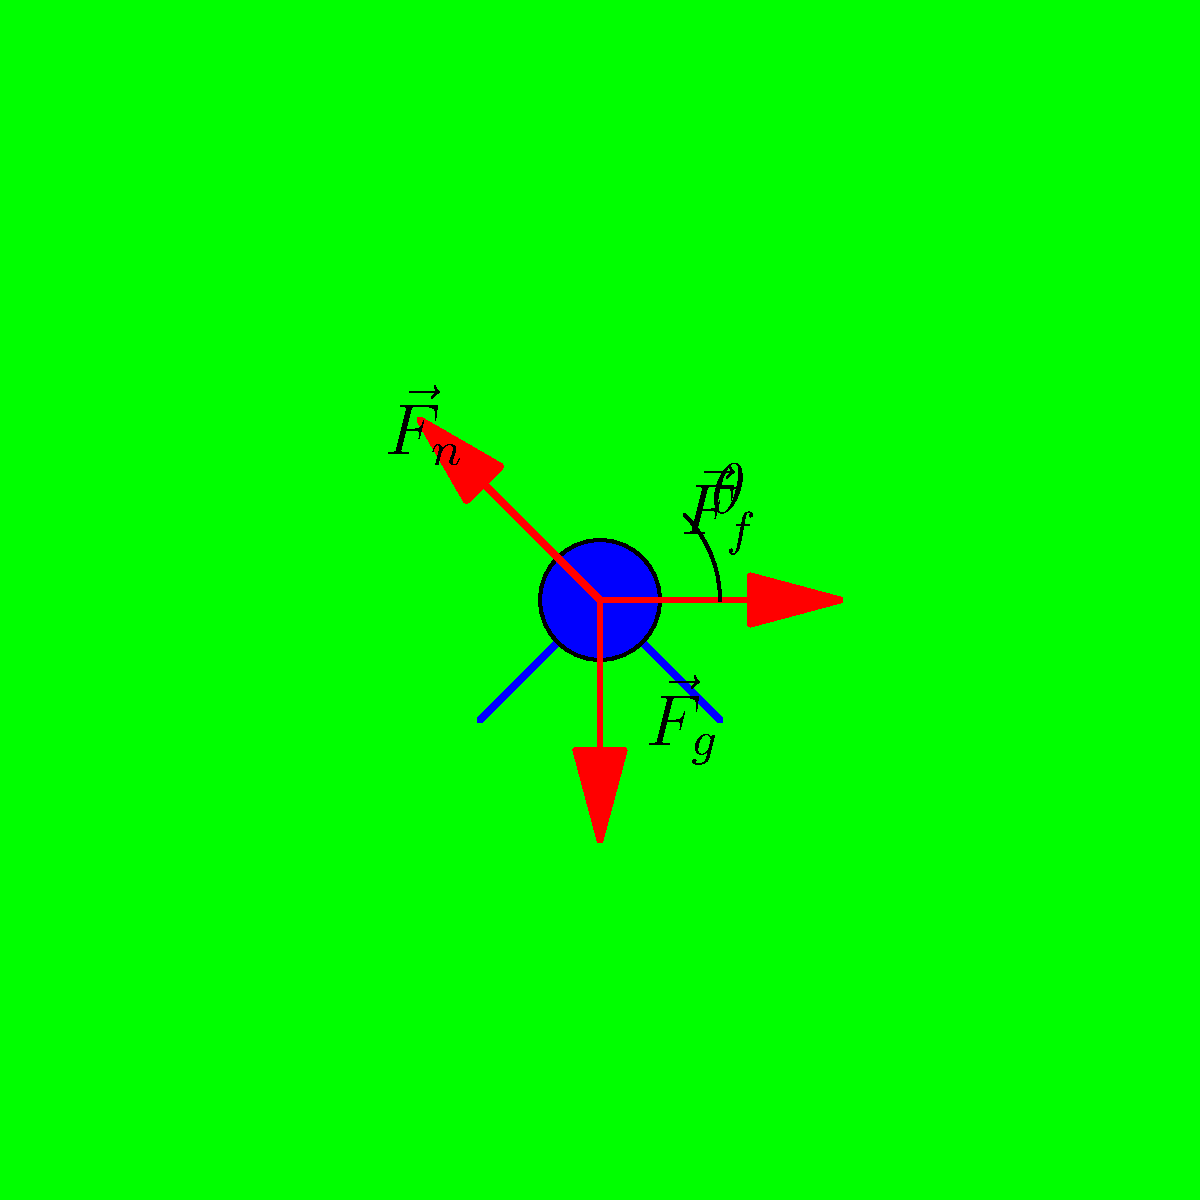During a crucial match against FC Dila Gori, a Dinamo Batumi player performs a slide tackle. The diagram shows the forces acting on the player: friction force $\vec{F}_f = 200\text{ N}$, normal force $\vec{F}_n = 250\text{ N}$, and gravitational force $\vec{F}_g = 700\text{ N}$. If the angle between $\vec{F}_f$ and $\vec{F}_n$ is $45°$, calculate the magnitude of the resultant force acting on the player. Let's approach this step-by-step:

1) We have three force vectors: $\vec{F}_f$, $\vec{F}_n$, and $\vec{F}_g$.

2) To find the resultant force, we need to add these vectors.

3) We can use the vector addition formula:
   $$\vec{F}_R = \vec{F}_f + \vec{F}_n + \vec{F}_g$$

4) To calculate the magnitude of the resultant force, we can use the formula:
   $$|\vec{F}_R| = \sqrt{F_x^2 + F_y^2}$$
   where $F_x$ and $F_y$ are the x and y components of the resultant force.

5) Let's calculate the components:
   $F_x = F_f - F_n \cos 45°$
   $F_y = F_n \sin 45° - F_g$

6) Substituting the values:
   $F_x = 200 - 250 \cos 45° = 200 - 250 \cdot \frac{\sqrt{2}}{2} \approx 23.22\text{ N}$
   $F_y = 250 \sin 45° - 700 = 250 \cdot \frac{\sqrt{2}}{2} - 700 \approx -523.22\text{ N}$

7) Now, let's use these in our magnitude formula:
   $$|\vec{F}_R| = \sqrt{(23.22)^2 + (-523.22)^2} \approx 523.77\text{ N}$$

Therefore, the magnitude of the resultant force acting on the player is approximately 523.77 N.
Answer: 523.77 N 